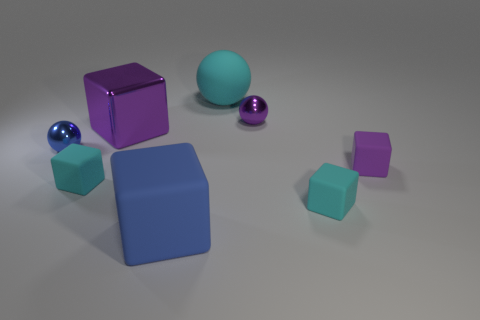There is a metal sphere that is the same color as the big matte block; what is its size?
Provide a short and direct response. Small. There is a shiny sphere in front of the tiny object behind the purple thing that is to the left of the large blue block; what is its size?
Your response must be concise. Small. How many tiny purple things are the same material as the cyan ball?
Provide a short and direct response. 1. What number of purple metal cylinders have the same size as the purple metallic cube?
Offer a very short reply. 0. What is the material of the tiny purple object that is in front of the small metal ball that is right of the large matte thing behind the big metal object?
Provide a short and direct response. Rubber. What number of things are purple rubber blocks or purple shiny blocks?
Offer a very short reply. 2. Are there any other things that have the same material as the blue block?
Your answer should be very brief. Yes. What is the shape of the small purple rubber object?
Give a very brief answer. Cube. There is a tiny purple object on the left side of the purple cube that is on the right side of the large blue rubber object; what is its shape?
Offer a very short reply. Sphere. Are the tiny cyan thing on the right side of the purple ball and the big blue cube made of the same material?
Your answer should be very brief. Yes. 